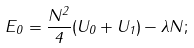<formula> <loc_0><loc_0><loc_500><loc_500>E _ { 0 } = \frac { N ^ { 2 } } { 4 } ( U _ { 0 } + U _ { 1 } ) - \lambda N ;</formula> 